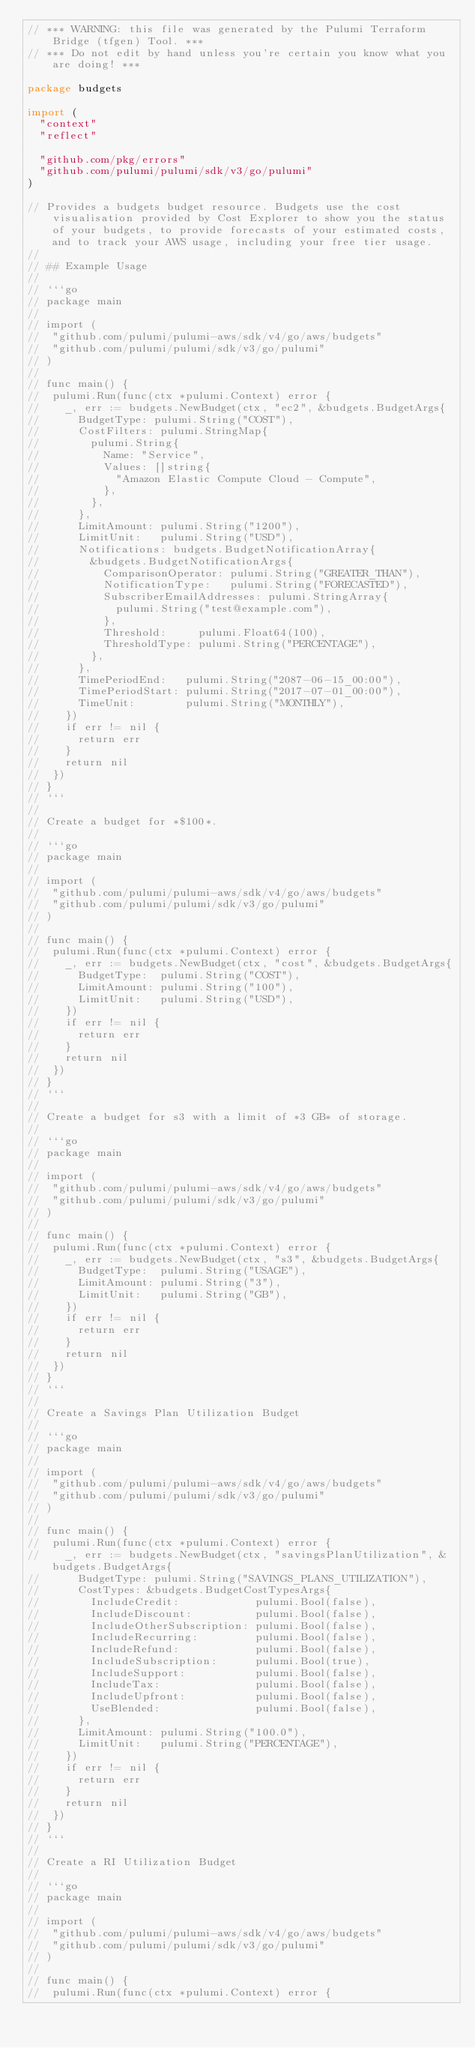<code> <loc_0><loc_0><loc_500><loc_500><_Go_>// *** WARNING: this file was generated by the Pulumi Terraform Bridge (tfgen) Tool. ***
// *** Do not edit by hand unless you're certain you know what you are doing! ***

package budgets

import (
	"context"
	"reflect"

	"github.com/pkg/errors"
	"github.com/pulumi/pulumi/sdk/v3/go/pulumi"
)

// Provides a budgets budget resource. Budgets use the cost visualisation provided by Cost Explorer to show you the status of your budgets, to provide forecasts of your estimated costs, and to track your AWS usage, including your free tier usage.
//
// ## Example Usage
//
// ```go
// package main
//
// import (
// 	"github.com/pulumi/pulumi-aws/sdk/v4/go/aws/budgets"
// 	"github.com/pulumi/pulumi/sdk/v3/go/pulumi"
// )
//
// func main() {
// 	pulumi.Run(func(ctx *pulumi.Context) error {
// 		_, err := budgets.NewBudget(ctx, "ec2", &budgets.BudgetArgs{
// 			BudgetType: pulumi.String("COST"),
// 			CostFilters: pulumi.StringMap{
// 				pulumi.String{
// 					Name: "Service",
// 					Values: []string{
// 						"Amazon Elastic Compute Cloud - Compute",
// 					},
// 				},
// 			},
// 			LimitAmount: pulumi.String("1200"),
// 			LimitUnit:   pulumi.String("USD"),
// 			Notifications: budgets.BudgetNotificationArray{
// 				&budgets.BudgetNotificationArgs{
// 					ComparisonOperator: pulumi.String("GREATER_THAN"),
// 					NotificationType:   pulumi.String("FORECASTED"),
// 					SubscriberEmailAddresses: pulumi.StringArray{
// 						pulumi.String("test@example.com"),
// 					},
// 					Threshold:     pulumi.Float64(100),
// 					ThresholdType: pulumi.String("PERCENTAGE"),
// 				},
// 			},
// 			TimePeriodEnd:   pulumi.String("2087-06-15_00:00"),
// 			TimePeriodStart: pulumi.String("2017-07-01_00:00"),
// 			TimeUnit:        pulumi.String("MONTHLY"),
// 		})
// 		if err != nil {
// 			return err
// 		}
// 		return nil
// 	})
// }
// ```
//
// Create a budget for *$100*.
//
// ```go
// package main
//
// import (
// 	"github.com/pulumi/pulumi-aws/sdk/v4/go/aws/budgets"
// 	"github.com/pulumi/pulumi/sdk/v3/go/pulumi"
// )
//
// func main() {
// 	pulumi.Run(func(ctx *pulumi.Context) error {
// 		_, err := budgets.NewBudget(ctx, "cost", &budgets.BudgetArgs{
// 			BudgetType:  pulumi.String("COST"),
// 			LimitAmount: pulumi.String("100"),
// 			LimitUnit:   pulumi.String("USD"),
// 		})
// 		if err != nil {
// 			return err
// 		}
// 		return nil
// 	})
// }
// ```
//
// Create a budget for s3 with a limit of *3 GB* of storage.
//
// ```go
// package main
//
// import (
// 	"github.com/pulumi/pulumi-aws/sdk/v4/go/aws/budgets"
// 	"github.com/pulumi/pulumi/sdk/v3/go/pulumi"
// )
//
// func main() {
// 	pulumi.Run(func(ctx *pulumi.Context) error {
// 		_, err := budgets.NewBudget(ctx, "s3", &budgets.BudgetArgs{
// 			BudgetType:  pulumi.String("USAGE"),
// 			LimitAmount: pulumi.String("3"),
// 			LimitUnit:   pulumi.String("GB"),
// 		})
// 		if err != nil {
// 			return err
// 		}
// 		return nil
// 	})
// }
// ```
//
// Create a Savings Plan Utilization Budget
//
// ```go
// package main
//
// import (
// 	"github.com/pulumi/pulumi-aws/sdk/v4/go/aws/budgets"
// 	"github.com/pulumi/pulumi/sdk/v3/go/pulumi"
// )
//
// func main() {
// 	pulumi.Run(func(ctx *pulumi.Context) error {
// 		_, err := budgets.NewBudget(ctx, "savingsPlanUtilization", &budgets.BudgetArgs{
// 			BudgetType: pulumi.String("SAVINGS_PLANS_UTILIZATION"),
// 			CostTypes: &budgets.BudgetCostTypesArgs{
// 				IncludeCredit:            pulumi.Bool(false),
// 				IncludeDiscount:          pulumi.Bool(false),
// 				IncludeOtherSubscription: pulumi.Bool(false),
// 				IncludeRecurring:         pulumi.Bool(false),
// 				IncludeRefund:            pulumi.Bool(false),
// 				IncludeSubscription:      pulumi.Bool(true),
// 				IncludeSupport:           pulumi.Bool(false),
// 				IncludeTax:               pulumi.Bool(false),
// 				IncludeUpfront:           pulumi.Bool(false),
// 				UseBlended:               pulumi.Bool(false),
// 			},
// 			LimitAmount: pulumi.String("100.0"),
// 			LimitUnit:   pulumi.String("PERCENTAGE"),
// 		})
// 		if err != nil {
// 			return err
// 		}
// 		return nil
// 	})
// }
// ```
//
// Create a RI Utilization Budget
//
// ```go
// package main
//
// import (
// 	"github.com/pulumi/pulumi-aws/sdk/v4/go/aws/budgets"
// 	"github.com/pulumi/pulumi/sdk/v3/go/pulumi"
// )
//
// func main() {
// 	pulumi.Run(func(ctx *pulumi.Context) error {</code> 